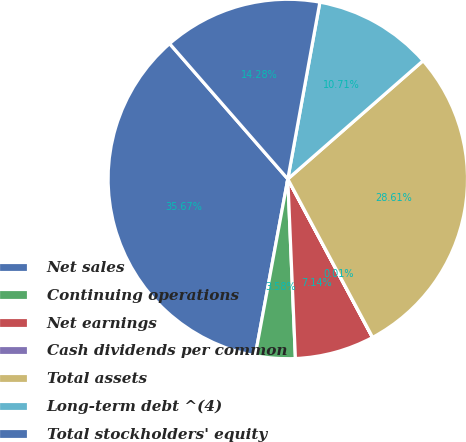Convert chart. <chart><loc_0><loc_0><loc_500><loc_500><pie_chart><fcel>Net sales<fcel>Continuing operations<fcel>Net earnings<fcel>Cash dividends per common<fcel>Total assets<fcel>Long-term debt ^(4)<fcel>Total stockholders' equity<nl><fcel>35.67%<fcel>3.58%<fcel>7.14%<fcel>0.01%<fcel>28.61%<fcel>10.71%<fcel>14.28%<nl></chart> 